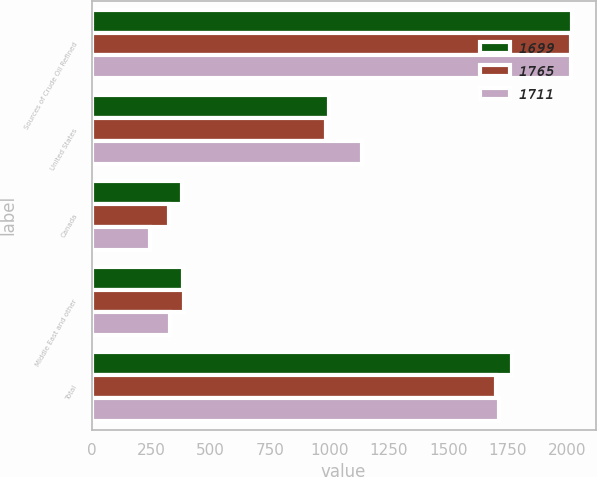<chart> <loc_0><loc_0><loc_500><loc_500><stacked_bar_chart><ecel><fcel>Sources of Crude Oil Refined<fcel>United States<fcel>Canada<fcel>Middle East and other<fcel>Total<nl><fcel>1699<fcel>2017<fcel>999<fcel>381<fcel>385<fcel>1765<nl><fcel>1765<fcel>2016<fcel>986<fcel>326<fcel>387<fcel>1699<nl><fcel>1711<fcel>2015<fcel>1138<fcel>244<fcel>329<fcel>1711<nl></chart> 